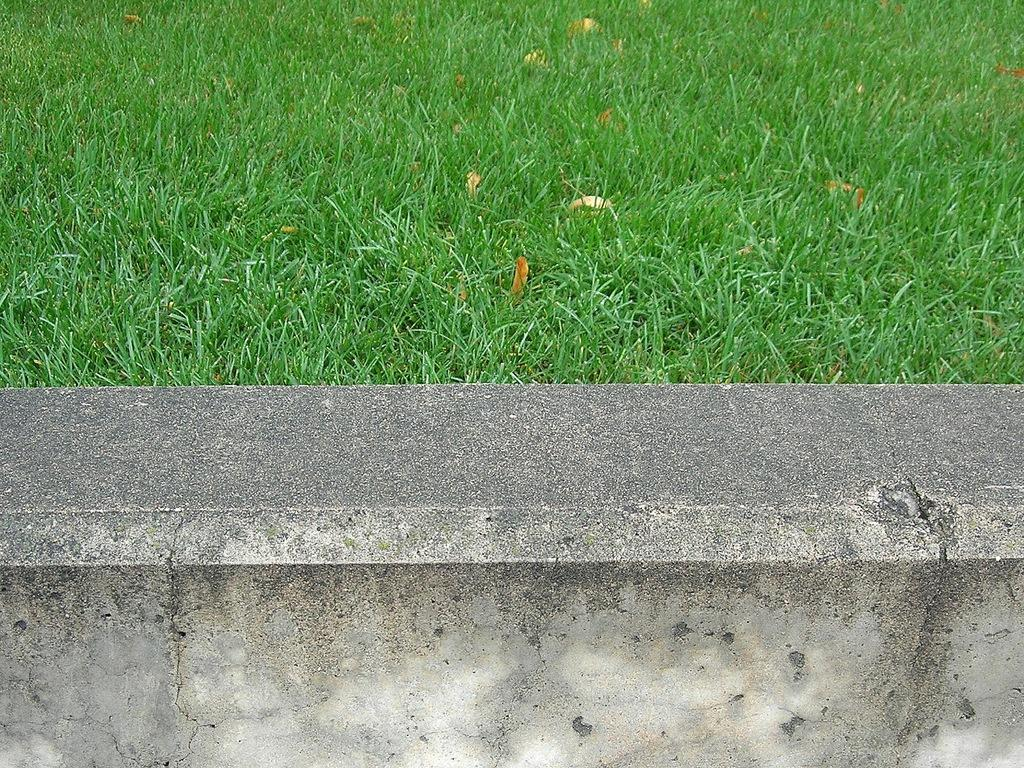What is located at the bottom of the image? There is a wall at the bottom of the image. What type of vegetation can be seen in the image? Grass is visible in the image. What else is present on the ground in the image? Leaves are present on the ground in the image. What type of basin can be seen in the image? There is no basin present in the image. What act is being performed by the leaves on the ground? The leaves on the ground are not performing any act; they are simply present on the ground. 